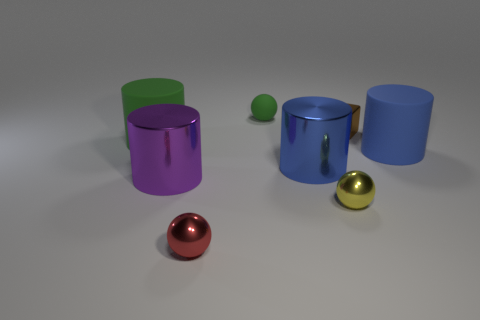What could be the function of these objects, and what do their colors tell us? While the objects in the image are simple geometric shapes, they might represent items in a conceptual space, like placeholders for furniture or components in a design mock-up. The vibrant colors ranging from green to blue, and then to purple, suggest a deliberate choice for visualization or aesthetic purposes, possibly to distinguish between different items or to create visual interest. 